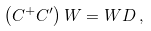Convert formula to latex. <formula><loc_0><loc_0><loc_500><loc_500>\left ( C ^ { + } C ^ { \prime } \right ) W = W D \, ,</formula> 